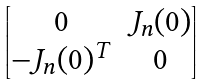Convert formula to latex. <formula><loc_0><loc_0><loc_500><loc_500>\begin{bmatrix} 0 & J _ { n } ( 0 ) \\ - J _ { n } ( 0 ) ^ { T } & 0 \\ \end{bmatrix}</formula> 